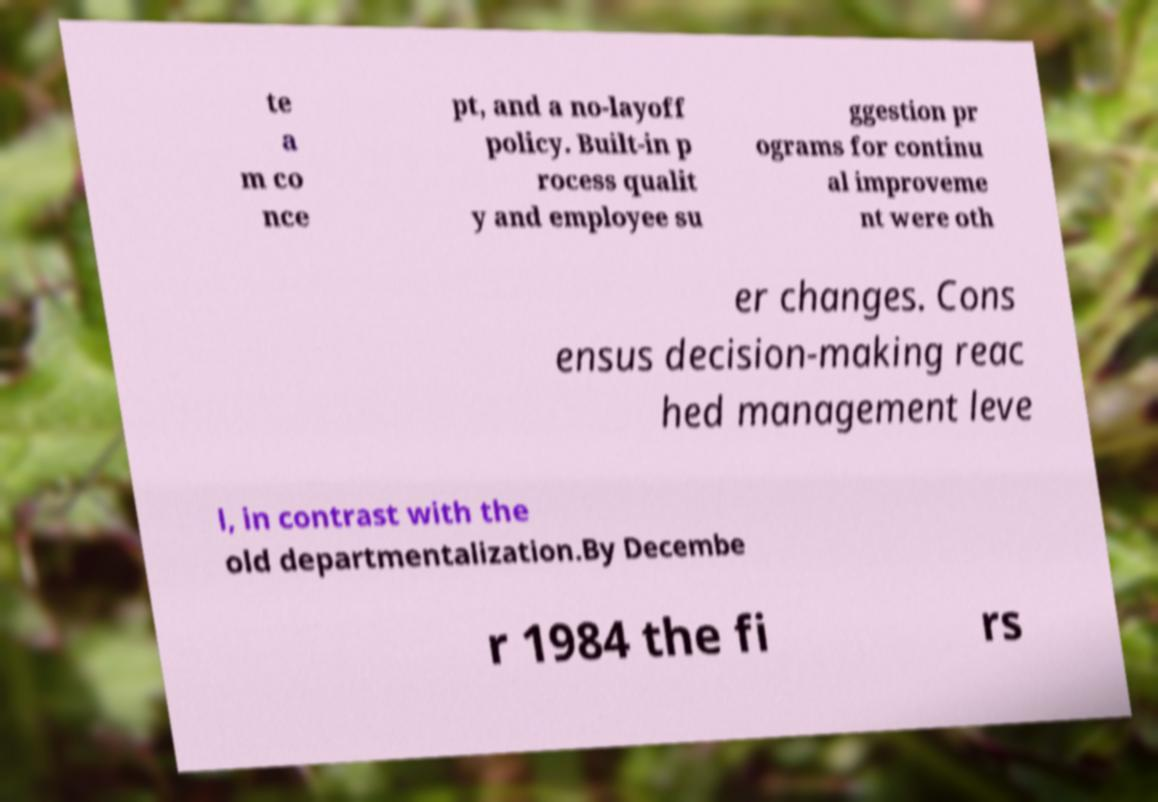I need the written content from this picture converted into text. Can you do that? te a m co nce pt, and a no-layoff policy. Built-in p rocess qualit y and employee su ggestion pr ograms for continu al improveme nt were oth er changes. Cons ensus decision-making reac hed management leve l, in contrast with the old departmentalization.By Decembe r 1984 the fi rs 